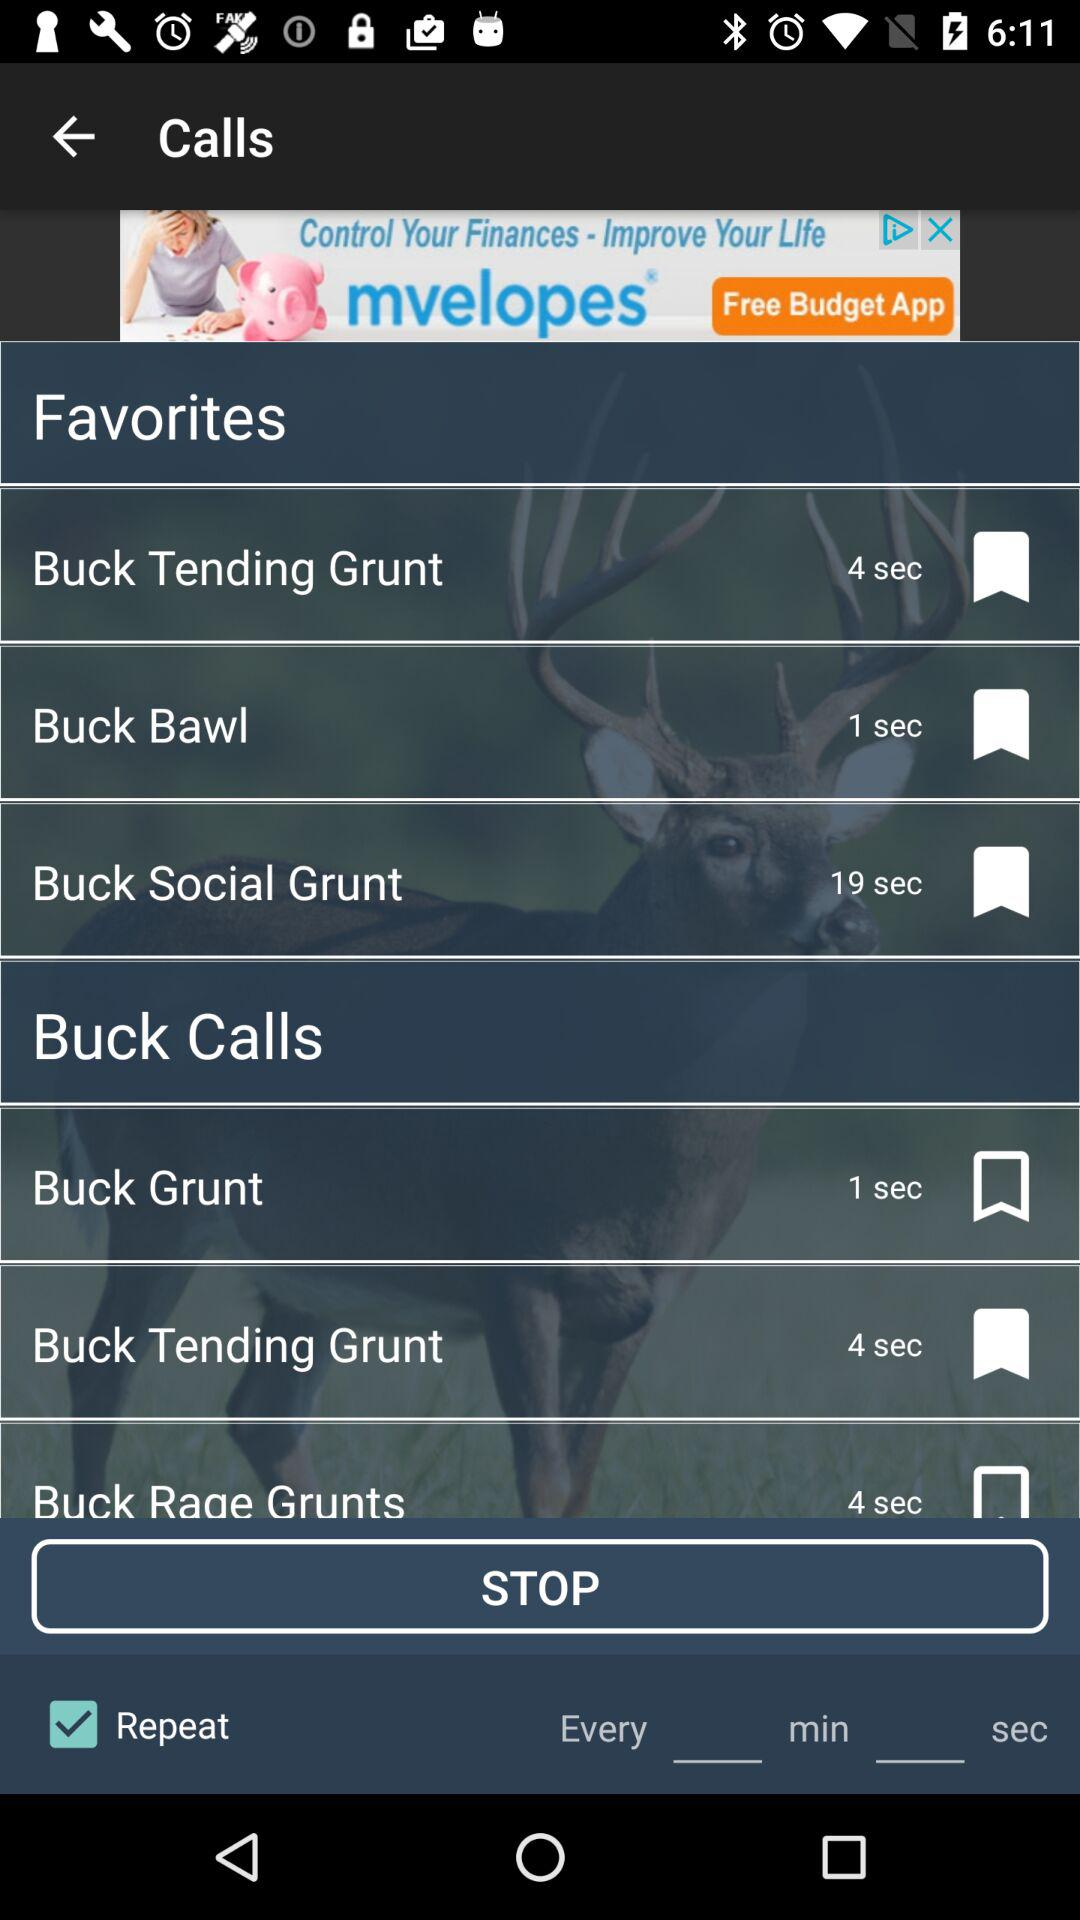How long is the "Buck Social Grunt" call? The "Buck Social Grunt" call is 19 seconds long. 